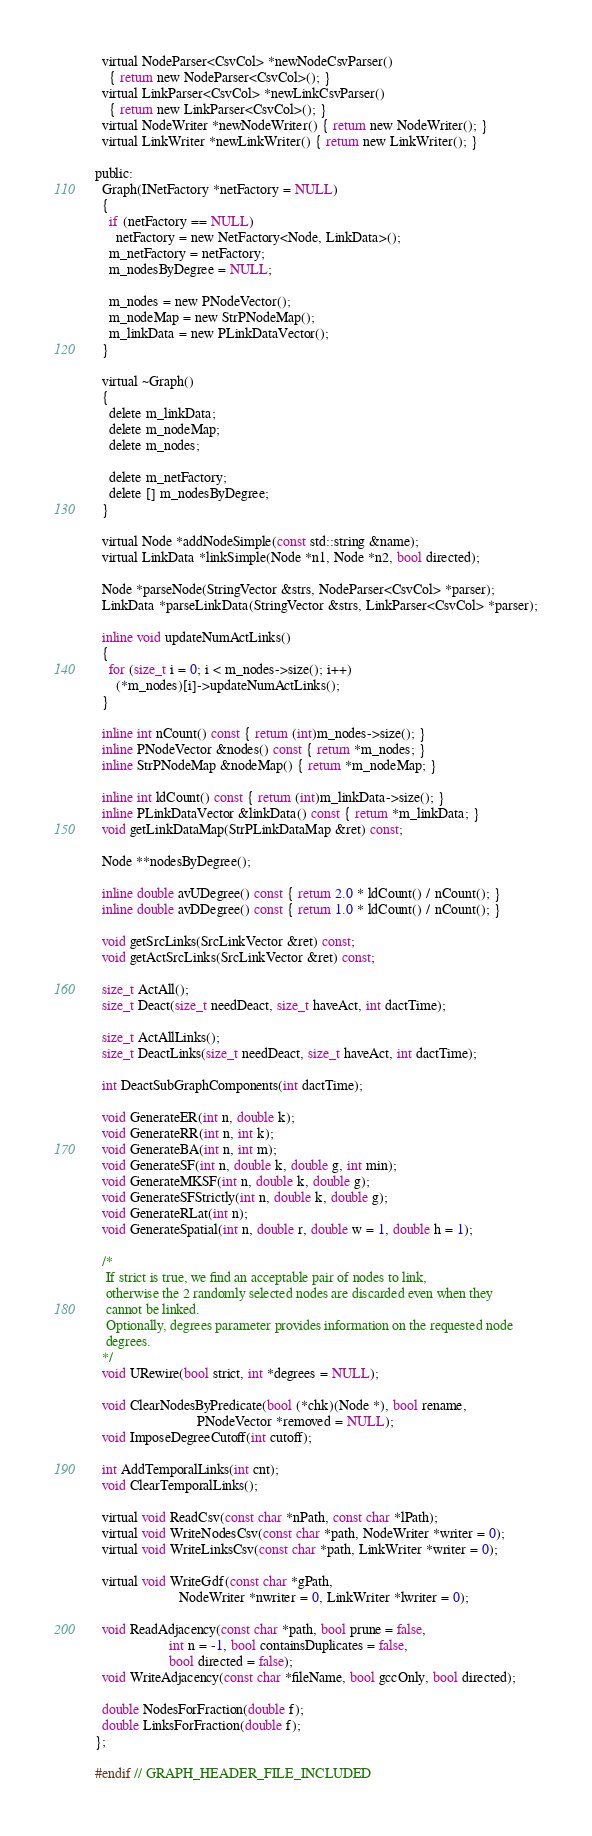<code> <loc_0><loc_0><loc_500><loc_500><_C_>
  virtual NodeParser<CsvCol> *newNodeCsvParser()
    { return new NodeParser<CsvCol>(); }
  virtual LinkParser<CsvCol> *newLinkCsvParser()
    { return new LinkParser<CsvCol>(); }
  virtual NodeWriter *newNodeWriter() { return new NodeWriter(); }
  virtual LinkWriter *newLinkWriter() { return new LinkWriter(); }

public:
  Graph(INetFactory *netFactory = NULL)
  {
    if (netFactory == NULL)
      netFactory = new NetFactory<Node, LinkData>();
    m_netFactory = netFactory;
    m_nodesByDegree = NULL;

    m_nodes = new PNodeVector();
    m_nodeMap = new StrPNodeMap();
    m_linkData = new PLinkDataVector();
  }

  virtual ~Graph()
  {
    delete m_linkData;
    delete m_nodeMap;
    delete m_nodes;

    delete m_netFactory;
    delete [] m_nodesByDegree;
  }

  virtual Node *addNodeSimple(const std::string &name);
  virtual LinkData *linkSimple(Node *n1, Node *n2, bool directed);

  Node *parseNode(StringVector &strs, NodeParser<CsvCol> *parser);
  LinkData *parseLinkData(StringVector &strs, LinkParser<CsvCol> *parser);

  inline void updateNumActLinks()
  {
    for (size_t i = 0; i < m_nodes->size(); i++)
      (*m_nodes)[i]->updateNumActLinks();
  }

  inline int nCount() const { return (int)m_nodes->size(); }
  inline PNodeVector &nodes() const { return *m_nodes; }
  inline StrPNodeMap &nodeMap() { return *m_nodeMap; }

  inline int ldCount() const { return (int)m_linkData->size(); }
  inline PLinkDataVector &linkData() const { return *m_linkData; }
  void getLinkDataMap(StrPLinkDataMap &ret) const;

  Node **nodesByDegree();

  inline double avUDegree() const { return 2.0 * ldCount() / nCount(); }
  inline double avDDegree() const { return 1.0 * ldCount() / nCount(); }

  void getSrcLinks(SrcLinkVector &ret) const;
  void getActSrcLinks(SrcLinkVector &ret) const;

  size_t ActAll();
  size_t Deact(size_t needDeact, size_t haveAct, int dactTime);

  size_t ActAllLinks();
  size_t DeactLinks(size_t needDeact, size_t haveAct, int dactTime);

  int DeactSubGraphComponents(int dactTime);

  void GenerateER(int n, double k);
  void GenerateRR(int n, int k);
  void GenerateBA(int n, int m);
  void GenerateSF(int n, double k, double g, int min);
  void GenerateMKSF(int n, double k, double g);
  void GenerateSFStrictly(int n, double k, double g);
  void GenerateRLat(int n);
  void GenerateSpatial(int n, double r, double w = 1, double h = 1);

  /*
   If strict is true, we find an acceptable pair of nodes to link,
   otherwise the 2 randomly selected nodes are discarded even when they
   cannot be linked.
   Optionally, degrees parameter provides information on the requested node
   degrees.
  */
  void URewire(bool strict, int *degrees = NULL);

  void ClearNodesByPredicate(bool (*chk)(Node *), bool rename,
                             PNodeVector *removed = NULL);
  void ImposeDegreeCutoff(int cutoff);

  int AddTemporalLinks(int cnt);
  void ClearTemporalLinks();

  virtual void ReadCsv(const char *nPath, const char *lPath);
  virtual void WriteNodesCsv(const char *path, NodeWriter *writer = 0);
  virtual void WriteLinksCsv(const char *path, LinkWriter *writer = 0);

  virtual void WriteGdf(const char *gPath,
                        NodeWriter *nwriter = 0, LinkWriter *lwriter = 0);

  void ReadAdjacency(const char *path, bool prune = false,
                     int n = -1, bool containsDuplicates = false,
                     bool directed = false);
  void WriteAdjacency(const char *fileName, bool gccOnly, bool directed);

  double NodesForFraction(double f);
  double LinksForFraction(double f);
};

#endif // GRAPH_HEADER_FILE_INCLUDED
</code> 